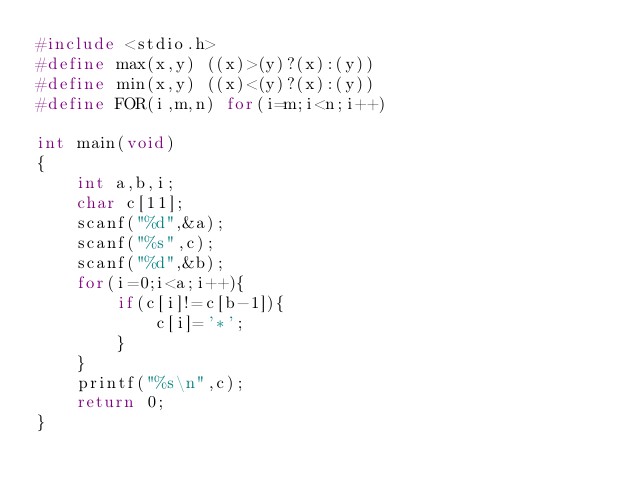<code> <loc_0><loc_0><loc_500><loc_500><_C_>#include <stdio.h>
#define max(x,y) ((x)>(y)?(x):(y))
#define min(x,y) ((x)<(y)?(x):(y))
#define FOR(i,m,n) for(i=m;i<n;i++)

int main(void)
{
	int a,b,i;
	char c[11];
	scanf("%d",&a);
	scanf("%s",c);
	scanf("%d",&b);
	for(i=0;i<a;i++){
		if(c[i]!=c[b-1]){
			c[i]='*';
		}
	}
	printf("%s\n",c);
	return 0;
}</code> 